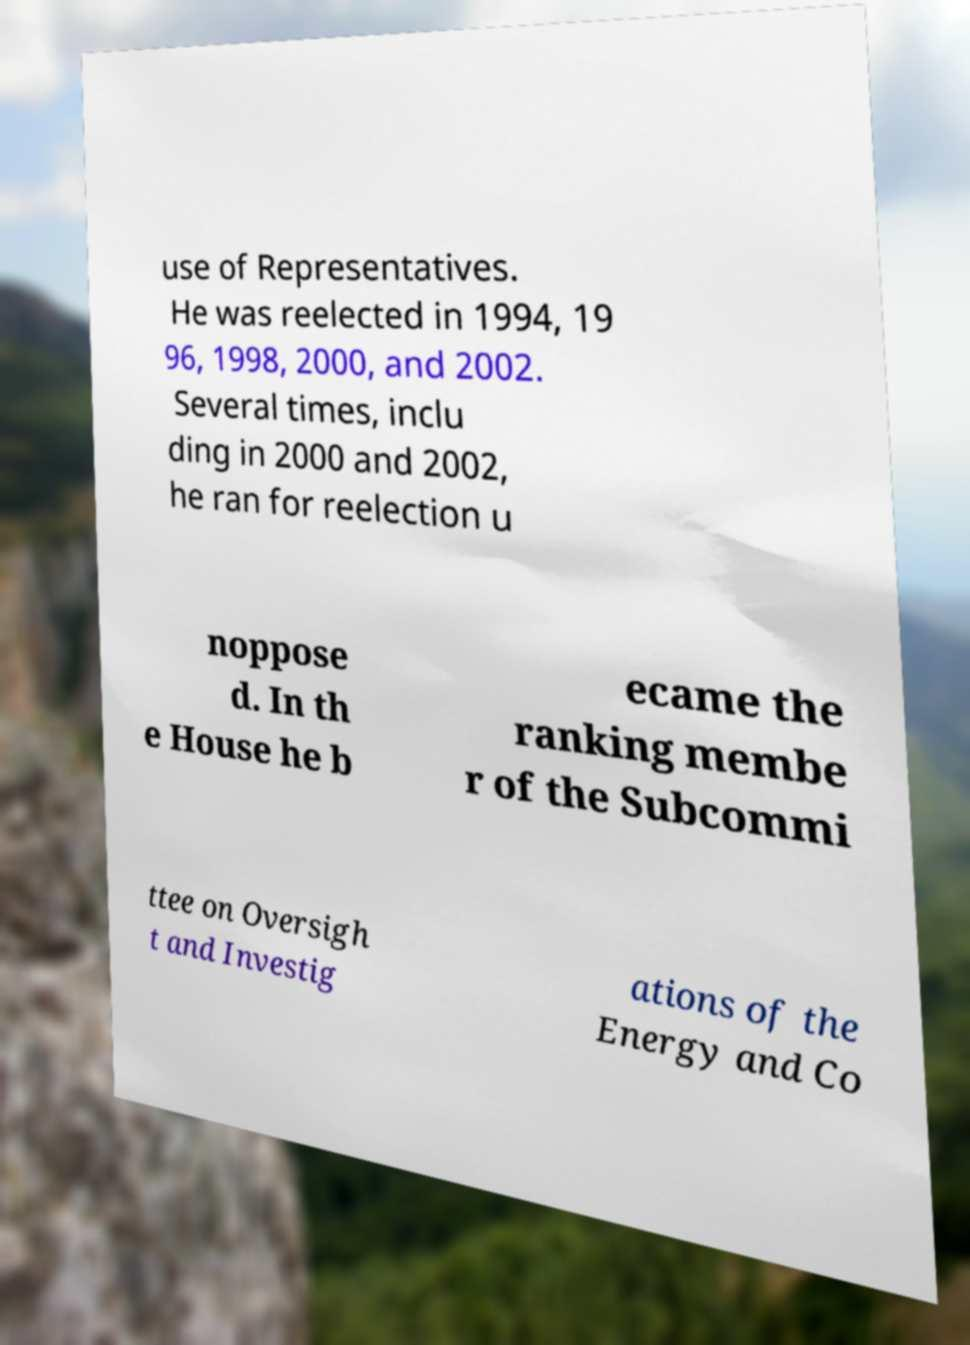What messages or text are displayed in this image? I need them in a readable, typed format. use of Representatives. He was reelected in 1994, 19 96, 1998, 2000, and 2002. Several times, inclu ding in 2000 and 2002, he ran for reelection u noppose d. In th e House he b ecame the ranking membe r of the Subcommi ttee on Oversigh t and Investig ations of the Energy and Co 